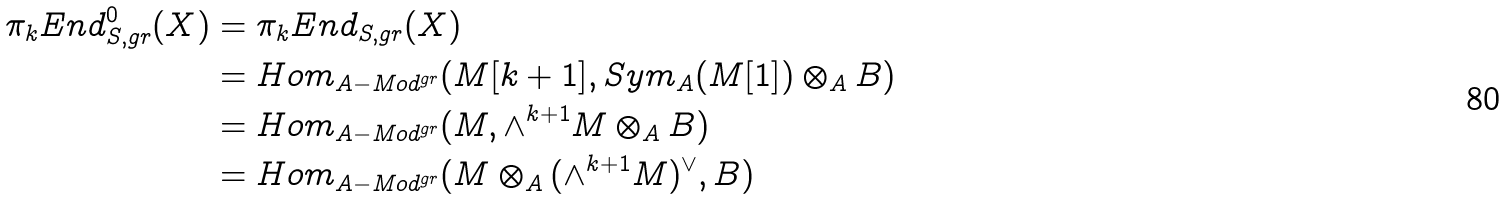<formula> <loc_0><loc_0><loc_500><loc_500>\pi _ { k } E n d ^ { 0 } _ { S , g r } ( X ) & = \pi _ { k } E n d _ { S , g r } ( X ) \\ & = H o m _ { A - M o d ^ { g r } } ( M [ k + 1 ] , S y m _ { A } ( M [ 1 ] ) \otimes _ { A } B ) \\ & = H o m _ { A - M o d ^ { g r } } ( M , \wedge ^ { k + 1 } M \otimes _ { A } B ) \\ & = H o m _ { A - M o d ^ { g r } } ( M \otimes _ { A } ( \wedge ^ { k + 1 } M ) ^ { \vee } , B )</formula> 